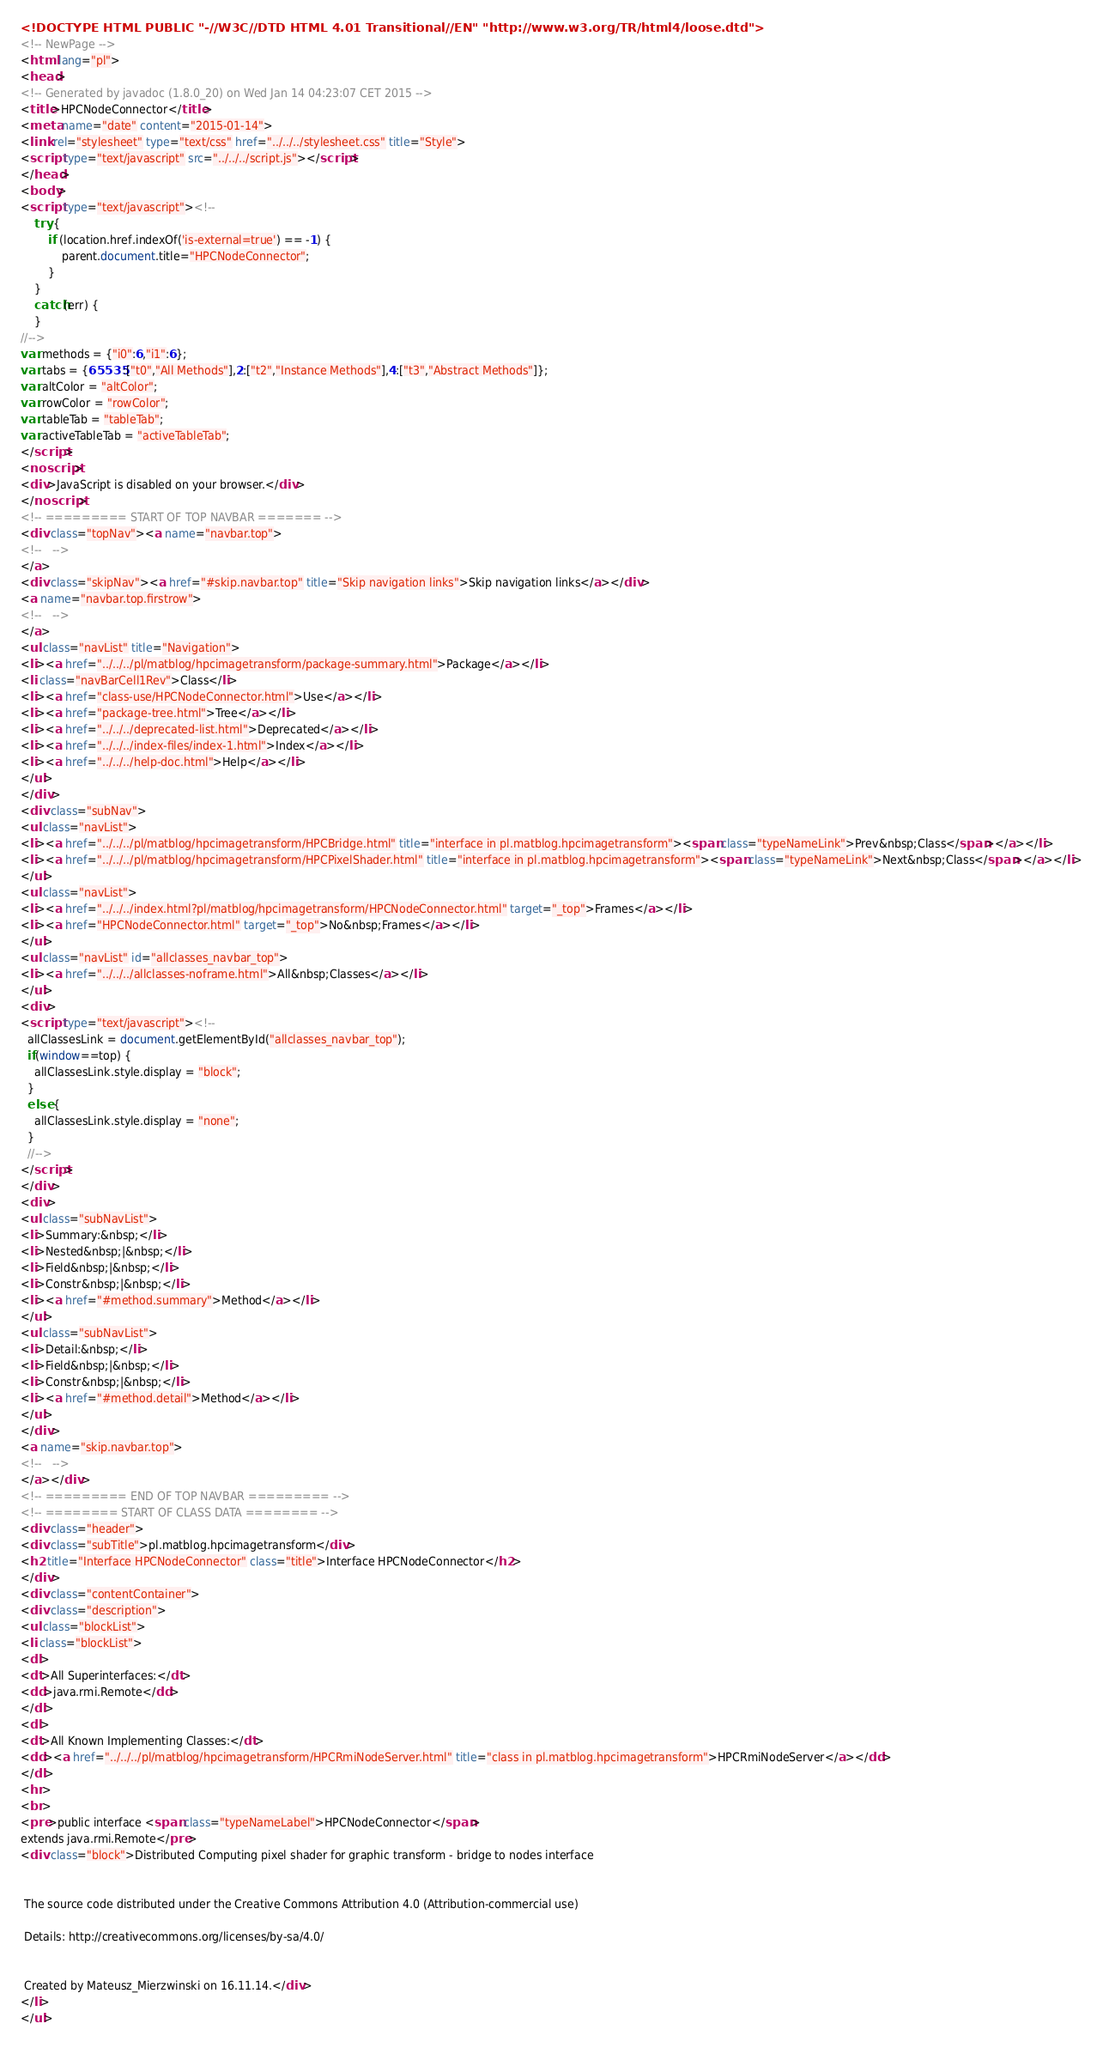<code> <loc_0><loc_0><loc_500><loc_500><_HTML_><!DOCTYPE HTML PUBLIC "-//W3C//DTD HTML 4.01 Transitional//EN" "http://www.w3.org/TR/html4/loose.dtd">
<!-- NewPage -->
<html lang="pl">
<head>
<!-- Generated by javadoc (1.8.0_20) on Wed Jan 14 04:23:07 CET 2015 -->
<title>HPCNodeConnector</title>
<meta name="date" content="2015-01-14">
<link rel="stylesheet" type="text/css" href="../../../stylesheet.css" title="Style">
<script type="text/javascript" src="../../../script.js"></script>
</head>
<body>
<script type="text/javascript"><!--
    try {
        if (location.href.indexOf('is-external=true') == -1) {
            parent.document.title="HPCNodeConnector";
        }
    }
    catch(err) {
    }
//-->
var methods = {"i0":6,"i1":6};
var tabs = {65535:["t0","All Methods"],2:["t2","Instance Methods"],4:["t3","Abstract Methods"]};
var altColor = "altColor";
var rowColor = "rowColor";
var tableTab = "tableTab";
var activeTableTab = "activeTableTab";
</script>
<noscript>
<div>JavaScript is disabled on your browser.</div>
</noscript>
<!-- ========= START OF TOP NAVBAR ======= -->
<div class="topNav"><a name="navbar.top">
<!--   -->
</a>
<div class="skipNav"><a href="#skip.navbar.top" title="Skip navigation links">Skip navigation links</a></div>
<a name="navbar.top.firstrow">
<!--   -->
</a>
<ul class="navList" title="Navigation">
<li><a href="../../../pl/matblog/hpcimagetransform/package-summary.html">Package</a></li>
<li class="navBarCell1Rev">Class</li>
<li><a href="class-use/HPCNodeConnector.html">Use</a></li>
<li><a href="package-tree.html">Tree</a></li>
<li><a href="../../../deprecated-list.html">Deprecated</a></li>
<li><a href="../../../index-files/index-1.html">Index</a></li>
<li><a href="../../../help-doc.html">Help</a></li>
</ul>
</div>
<div class="subNav">
<ul class="navList">
<li><a href="../../../pl/matblog/hpcimagetransform/HPCBridge.html" title="interface in pl.matblog.hpcimagetransform"><span class="typeNameLink">Prev&nbsp;Class</span></a></li>
<li><a href="../../../pl/matblog/hpcimagetransform/HPCPixelShader.html" title="interface in pl.matblog.hpcimagetransform"><span class="typeNameLink">Next&nbsp;Class</span></a></li>
</ul>
<ul class="navList">
<li><a href="../../../index.html?pl/matblog/hpcimagetransform/HPCNodeConnector.html" target="_top">Frames</a></li>
<li><a href="HPCNodeConnector.html" target="_top">No&nbsp;Frames</a></li>
</ul>
<ul class="navList" id="allclasses_navbar_top">
<li><a href="../../../allclasses-noframe.html">All&nbsp;Classes</a></li>
</ul>
<div>
<script type="text/javascript"><!--
  allClassesLink = document.getElementById("allclasses_navbar_top");
  if(window==top) {
    allClassesLink.style.display = "block";
  }
  else {
    allClassesLink.style.display = "none";
  }
  //-->
</script>
</div>
<div>
<ul class="subNavList">
<li>Summary:&nbsp;</li>
<li>Nested&nbsp;|&nbsp;</li>
<li>Field&nbsp;|&nbsp;</li>
<li>Constr&nbsp;|&nbsp;</li>
<li><a href="#method.summary">Method</a></li>
</ul>
<ul class="subNavList">
<li>Detail:&nbsp;</li>
<li>Field&nbsp;|&nbsp;</li>
<li>Constr&nbsp;|&nbsp;</li>
<li><a href="#method.detail">Method</a></li>
</ul>
</div>
<a name="skip.navbar.top">
<!--   -->
</a></div>
<!-- ========= END OF TOP NAVBAR ========= -->
<!-- ======== START OF CLASS DATA ======== -->
<div class="header">
<div class="subTitle">pl.matblog.hpcimagetransform</div>
<h2 title="Interface HPCNodeConnector" class="title">Interface HPCNodeConnector</h2>
</div>
<div class="contentContainer">
<div class="description">
<ul class="blockList">
<li class="blockList">
<dl>
<dt>All Superinterfaces:</dt>
<dd>java.rmi.Remote</dd>
</dl>
<dl>
<dt>All Known Implementing Classes:</dt>
<dd><a href="../../../pl/matblog/hpcimagetransform/HPCRmiNodeServer.html" title="class in pl.matblog.hpcimagetransform">HPCRmiNodeServer</a></dd>
</dl>
<hr>
<br>
<pre>public interface <span class="typeNameLabel">HPCNodeConnector</span>
extends java.rmi.Remote</pre>
<div class="block">Distributed Computing pixel shader for graphic transform - bridge to nodes interface


 The source code distributed under the Creative Commons Attribution 4.0 (Attribution-commercial use)

 Details: http://creativecommons.org/licenses/by-sa/4.0/


 Created by Mateusz_Mierzwinski on 16.11.14.</div>
</li>
</ul></code> 